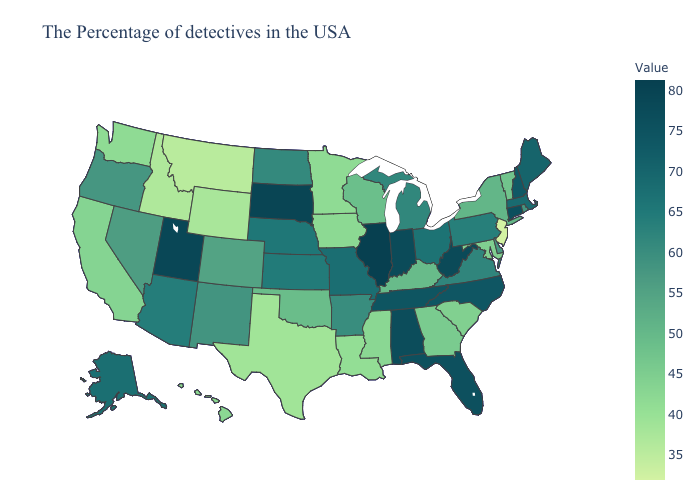Does Montana have the highest value in the West?
Give a very brief answer. No. Does Florida have a lower value than Illinois?
Keep it brief. Yes. Which states have the highest value in the USA?
Be succinct. Illinois. Which states hav the highest value in the West?
Short answer required. Utah. Does Illinois have the highest value in the USA?
Short answer required. Yes. Among the states that border Washington , does Oregon have the lowest value?
Answer briefly. No. 